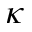Convert formula to latex. <formula><loc_0><loc_0><loc_500><loc_500>\kappa</formula> 